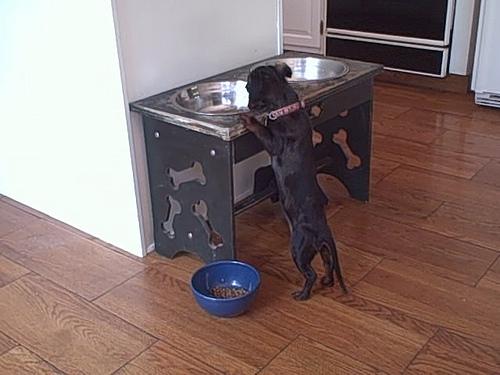Do you think this dog lives with other dogs?
Write a very short answer. Yes. Does this dog have all four feet on the ground?
Be succinct. No. What kind of dog is that?
Short answer required. Lab. 